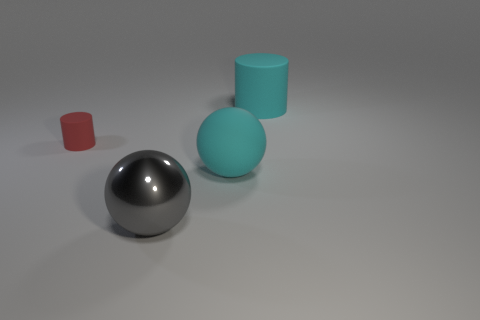Subtract 1 cylinders. How many cylinders are left? 1 Add 2 large cyan cylinders. How many objects exist? 6 Subtract all brown spheres. How many yellow cylinders are left? 0 Subtract all small green cylinders. Subtract all tiny red cylinders. How many objects are left? 3 Add 3 tiny things. How many tiny things are left? 4 Add 4 gray balls. How many gray balls exist? 5 Subtract all red cylinders. How many cylinders are left? 1 Subtract 0 blue cylinders. How many objects are left? 4 Subtract all gray balls. Subtract all blue blocks. How many balls are left? 1 